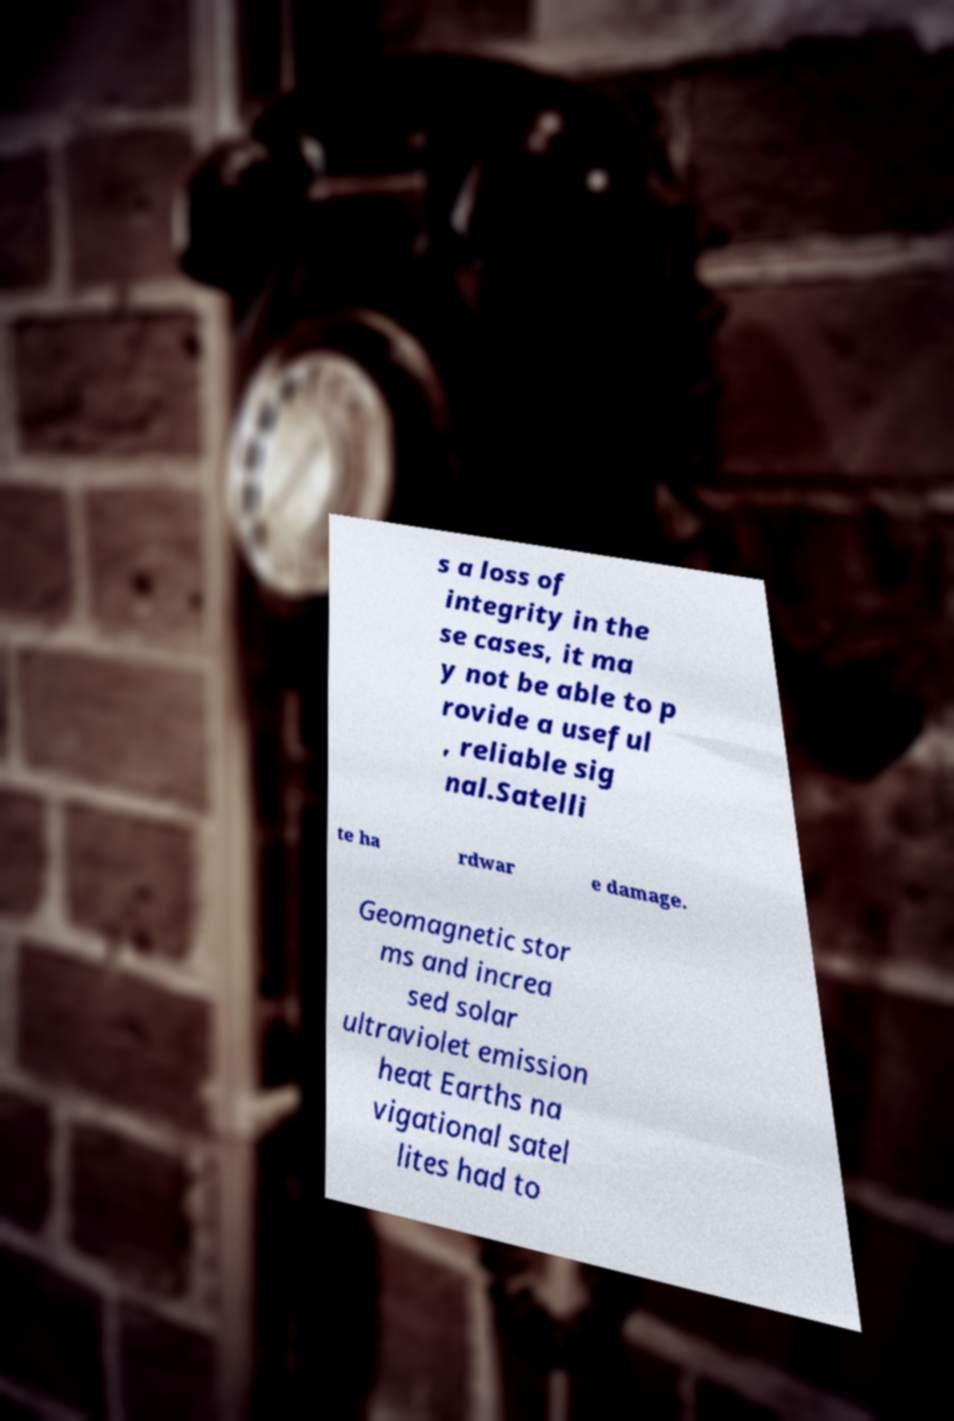Can you read and provide the text displayed in the image?This photo seems to have some interesting text. Can you extract and type it out for me? s a loss of integrity in the se cases, it ma y not be able to p rovide a useful , reliable sig nal.Satelli te ha rdwar e damage. Geomagnetic stor ms and increa sed solar ultraviolet emission heat Earths na vigational satel lites had to 